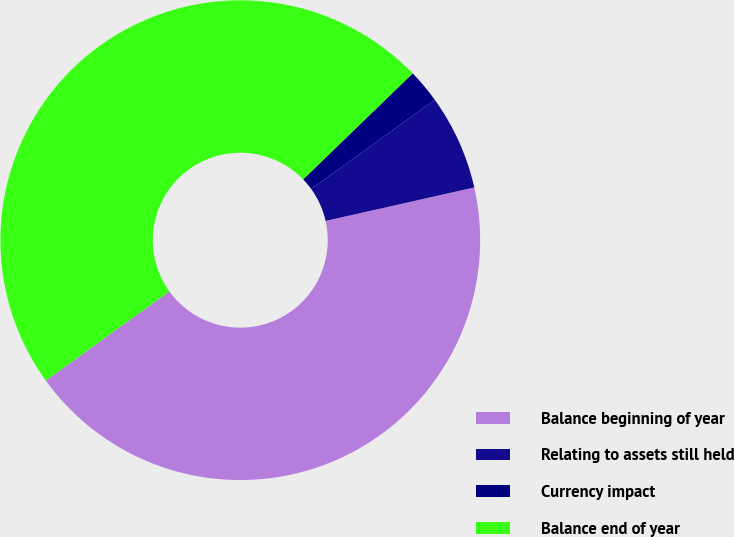Convert chart. <chart><loc_0><loc_0><loc_500><loc_500><pie_chart><fcel>Balance beginning of year<fcel>Relating to assets still held<fcel>Currency impact<fcel>Balance end of year<nl><fcel>43.58%<fcel>6.42%<fcel>2.29%<fcel>47.71%<nl></chart> 